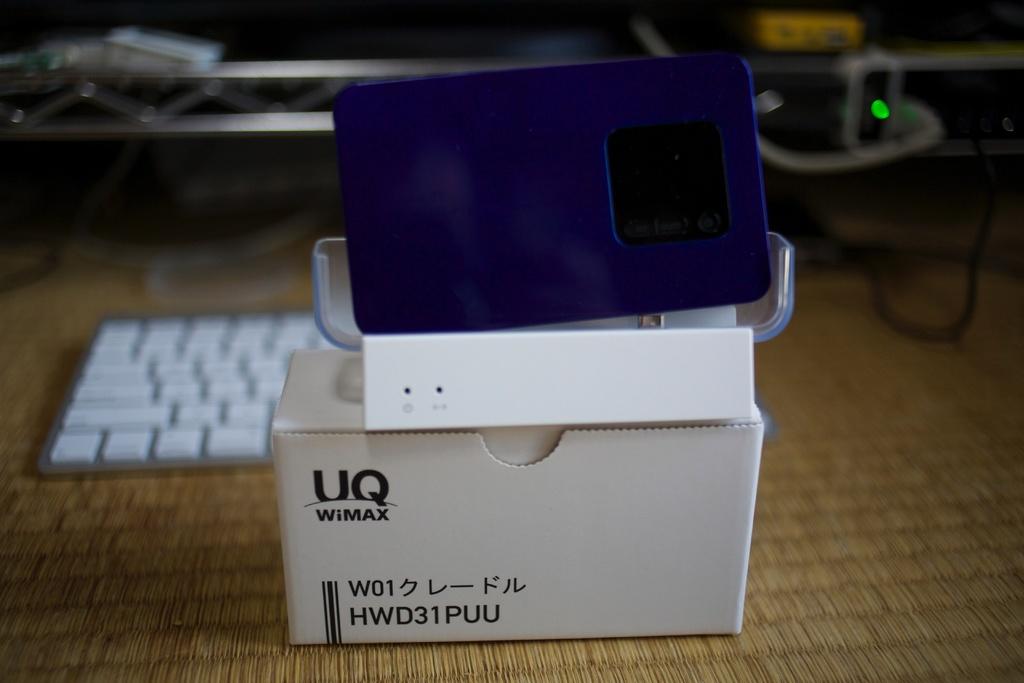What is the brand of this product?
Your answer should be compact. Uq wimax. What is the number and letter combination on the bottom left hand corner of the box?
Provide a short and direct response. Hwd31puu. 